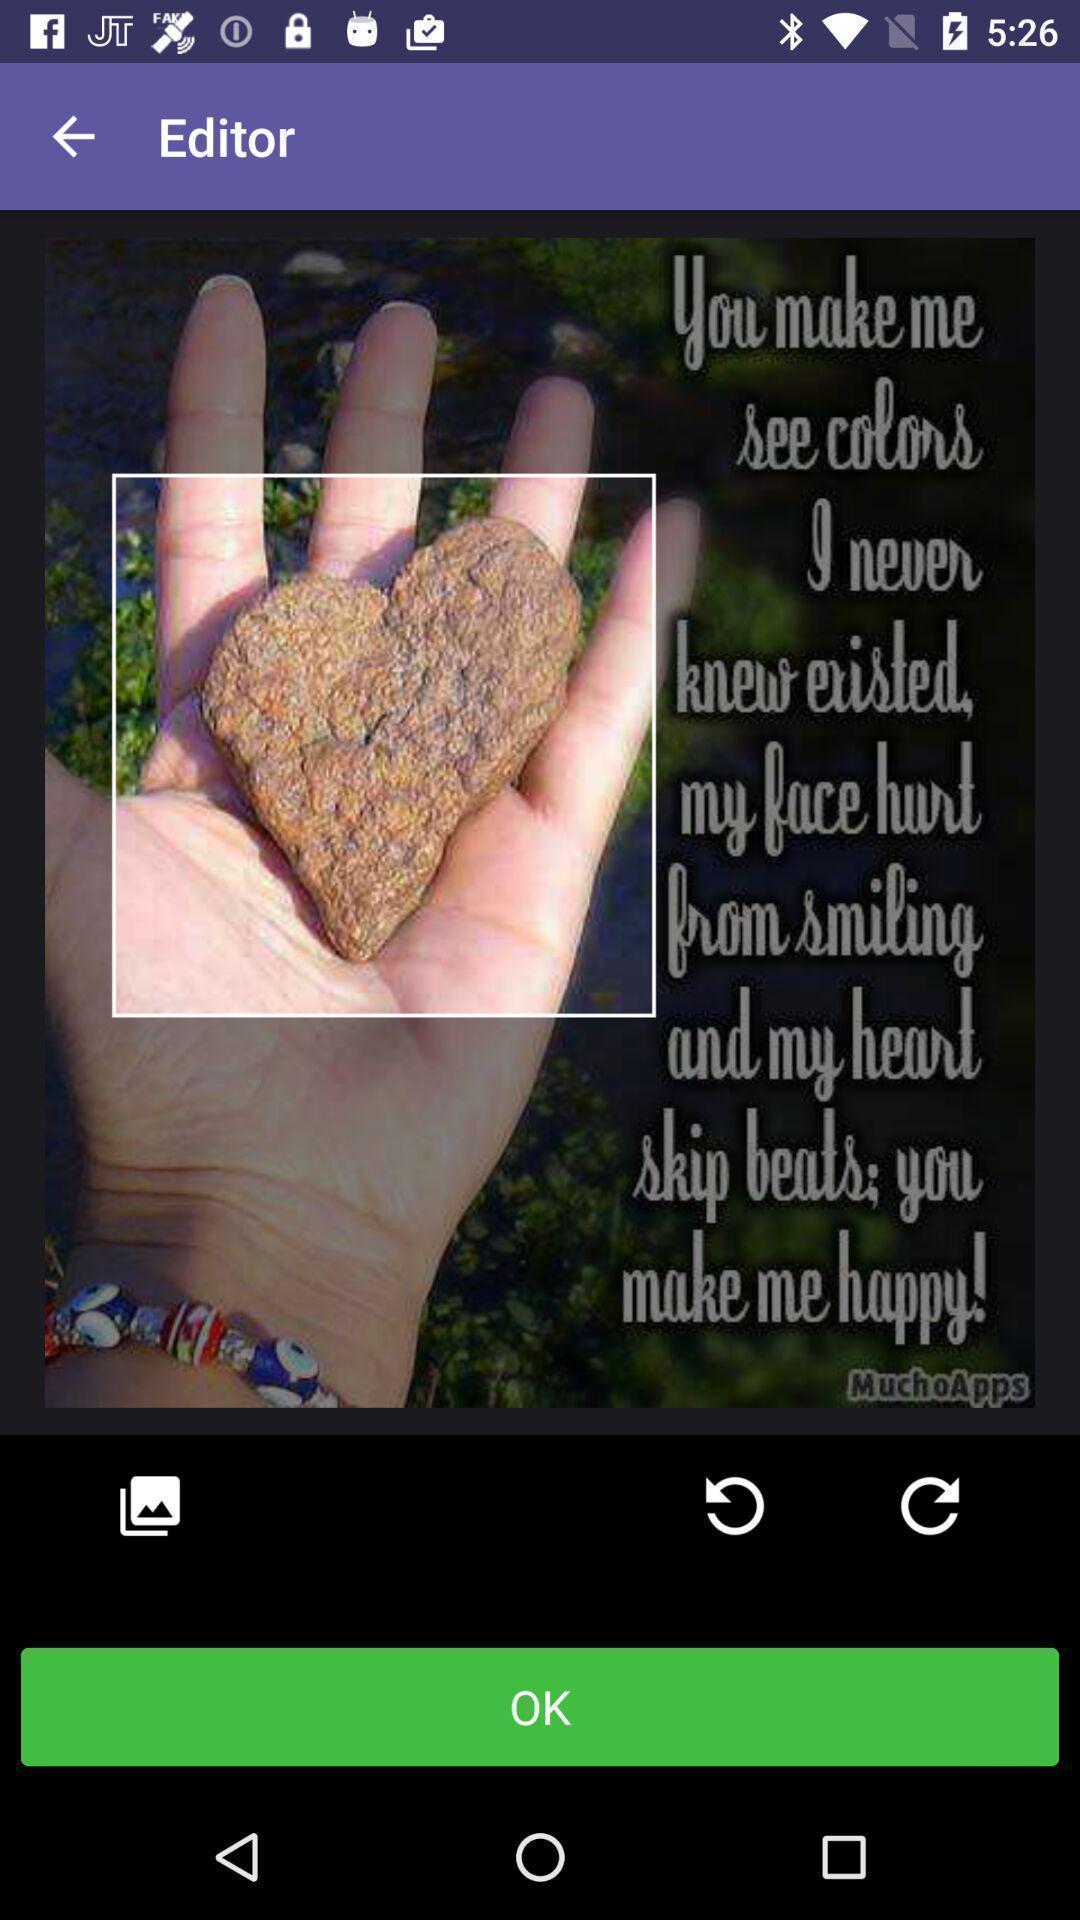Describe the content in this image. Screen showing cropping of an image. 